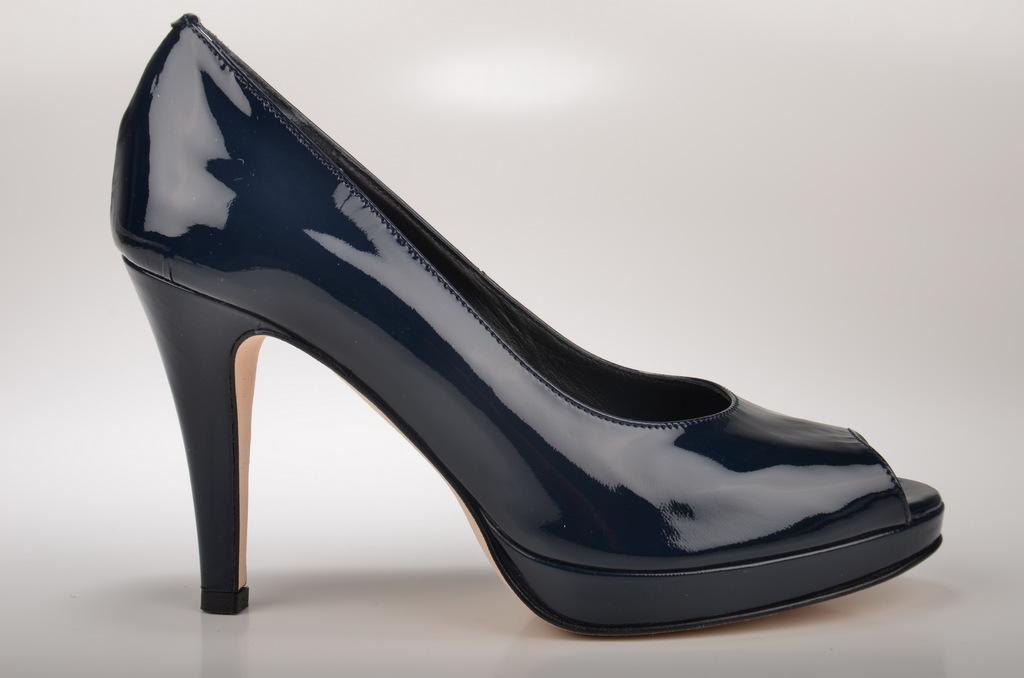What type of shoe is in the image? There is a high heel shoe in the image. What color is the shoe? The shoe is black in color. What color is the background of the image? The background of the image is white. Can you see any hills in the background of the image? There are no hills visible in the image, as the background is white. Are there any ants crawling on the shoe in the image? There are no ants present in the image; it only features a high heel shoe. 